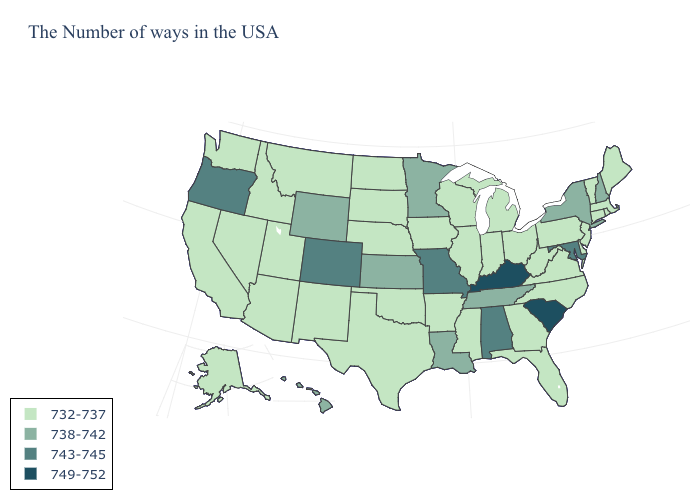What is the value of New Hampshire?
Keep it brief. 738-742. Which states have the highest value in the USA?
Give a very brief answer. South Carolina, Kentucky. What is the value of Idaho?
Short answer required. 732-737. Does Kentucky have the highest value in the USA?
Quick response, please. Yes. Which states have the lowest value in the USA?
Write a very short answer. Maine, Massachusetts, Rhode Island, Vermont, Connecticut, New Jersey, Delaware, Pennsylvania, Virginia, North Carolina, West Virginia, Ohio, Florida, Georgia, Michigan, Indiana, Wisconsin, Illinois, Mississippi, Arkansas, Iowa, Nebraska, Oklahoma, Texas, South Dakota, North Dakota, New Mexico, Utah, Montana, Arizona, Idaho, Nevada, California, Washington, Alaska. What is the highest value in the MidWest ?
Short answer required. 743-745. Among the states that border Illinois , does Indiana have the highest value?
Quick response, please. No. Does Rhode Island have the highest value in the Northeast?
Give a very brief answer. No. Name the states that have a value in the range 738-742?
Give a very brief answer. New Hampshire, New York, Tennessee, Louisiana, Minnesota, Kansas, Wyoming, Hawaii. What is the lowest value in the Northeast?
Quick response, please. 732-737. What is the value of Wisconsin?
Concise answer only. 732-737. What is the value of Missouri?
Quick response, please. 743-745. Which states have the lowest value in the MidWest?
Be succinct. Ohio, Michigan, Indiana, Wisconsin, Illinois, Iowa, Nebraska, South Dakota, North Dakota. What is the value of Pennsylvania?
Give a very brief answer. 732-737. Does Massachusetts have the lowest value in the Northeast?
Concise answer only. Yes. 